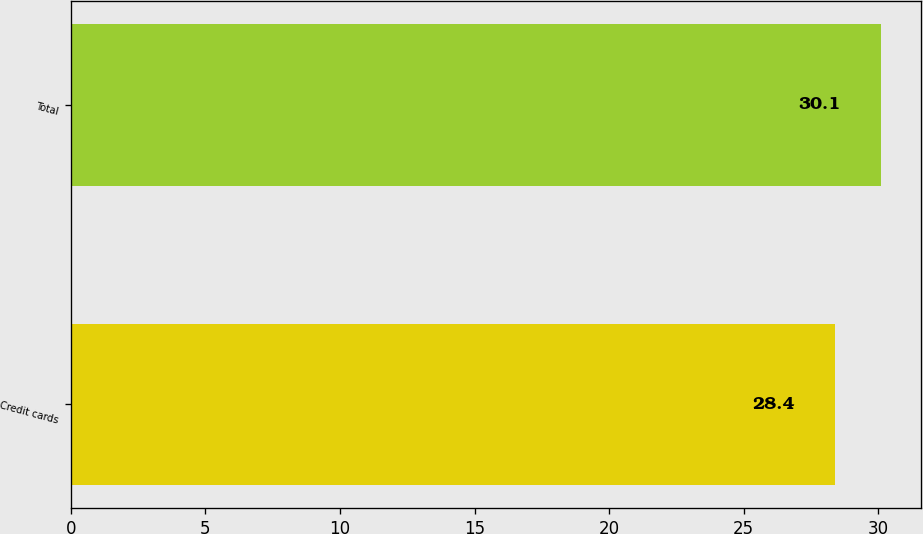Convert chart. <chart><loc_0><loc_0><loc_500><loc_500><bar_chart><fcel>Credit cards<fcel>Total<nl><fcel>28.4<fcel>30.1<nl></chart> 